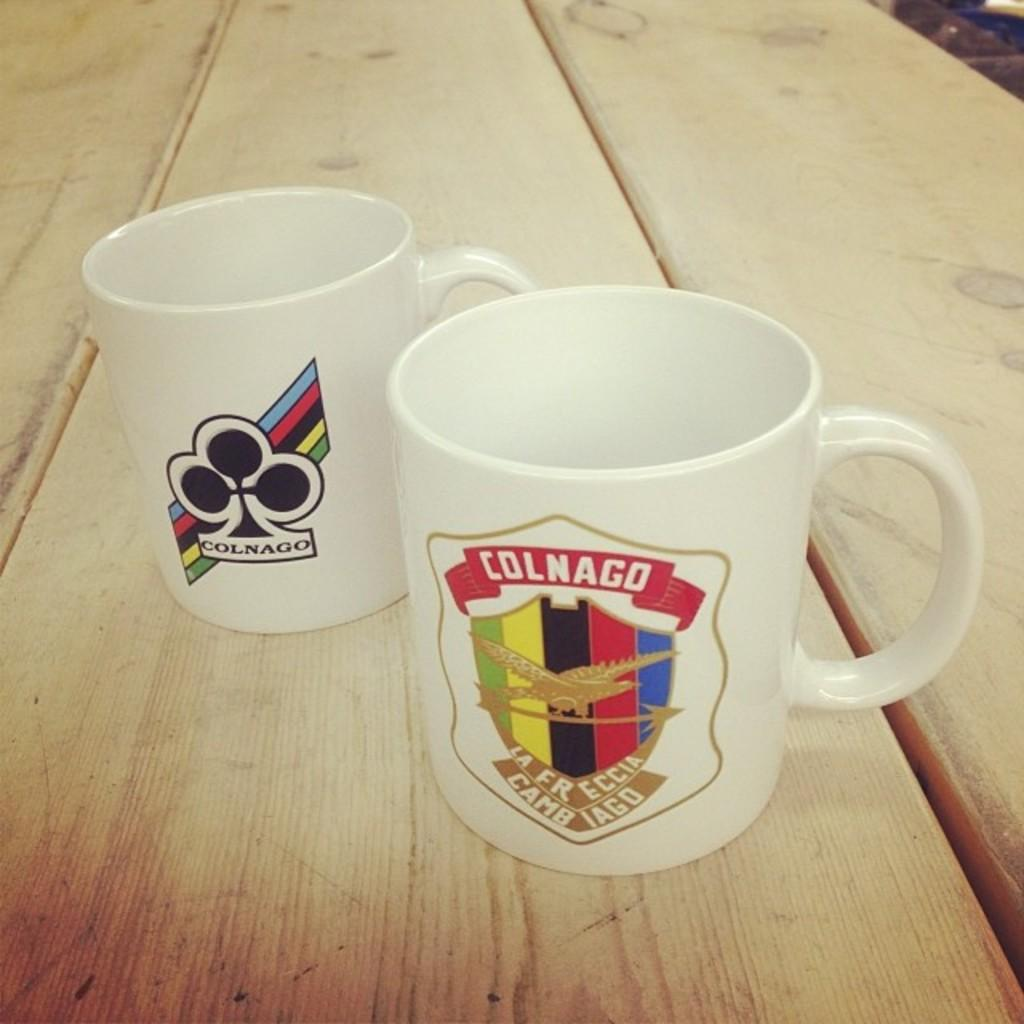How many cups are visible in the image? There are two cups in the image. Where are the cups located? The cups are on a platform. What distinguishes the two cups from each other? Each cup has a different logo. What type of answer can be seen written on the cups in the image? There is no answer written on the cups in the image; they only have different logos. 